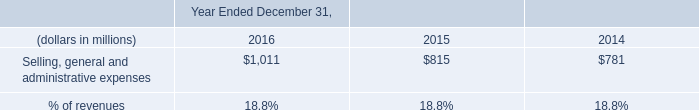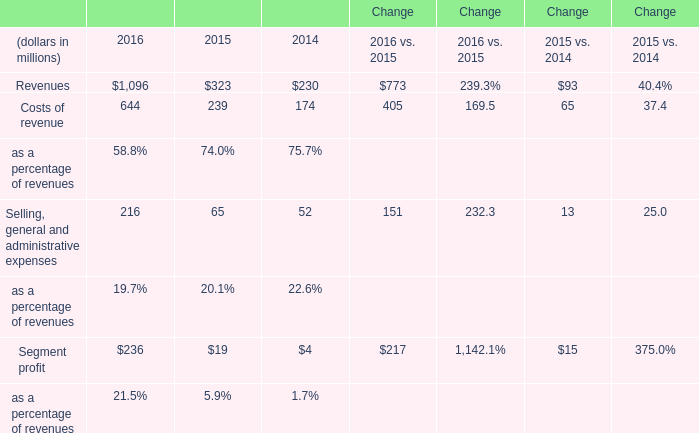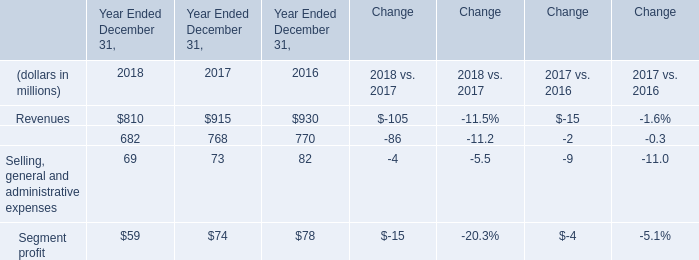What was the sum of elements without those elements smaller than 300 in 2016? (in million) 
Computations: (1096 + 644)
Answer: 1740.0. 